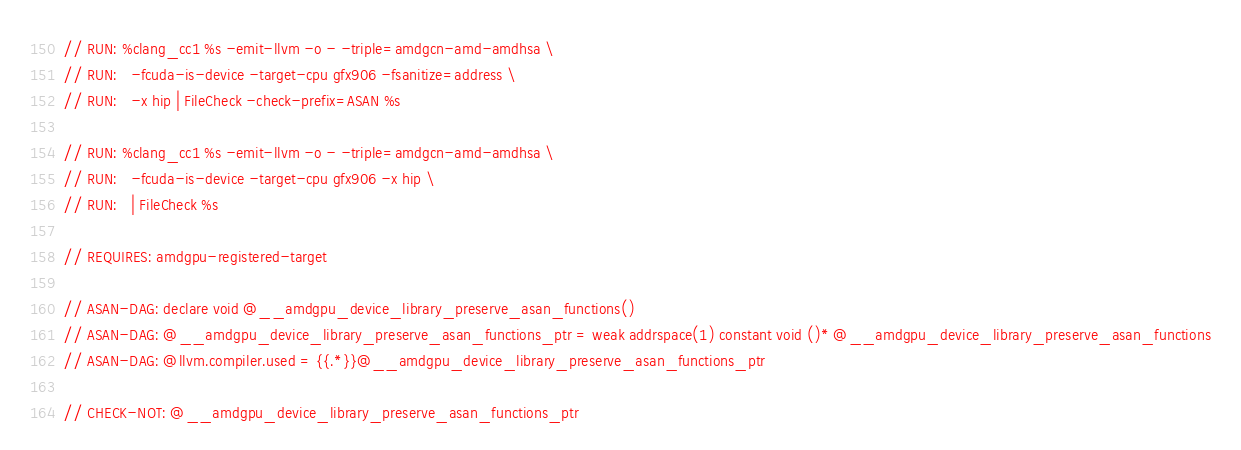<code> <loc_0><loc_0><loc_500><loc_500><_Cuda_>// RUN: %clang_cc1 %s -emit-llvm -o - -triple=amdgcn-amd-amdhsa \
// RUN:   -fcuda-is-device -target-cpu gfx906 -fsanitize=address \
// RUN:   -x hip | FileCheck -check-prefix=ASAN %s

// RUN: %clang_cc1 %s -emit-llvm -o - -triple=amdgcn-amd-amdhsa \
// RUN:   -fcuda-is-device -target-cpu gfx906 -x hip \
// RUN:   | FileCheck %s

// REQUIRES: amdgpu-registered-target

// ASAN-DAG: declare void @__amdgpu_device_library_preserve_asan_functions()
// ASAN-DAG: @__amdgpu_device_library_preserve_asan_functions_ptr = weak addrspace(1) constant void ()* @__amdgpu_device_library_preserve_asan_functions
// ASAN-DAG: @llvm.compiler.used = {{.*}}@__amdgpu_device_library_preserve_asan_functions_ptr

// CHECK-NOT: @__amdgpu_device_library_preserve_asan_functions_ptr
</code> 